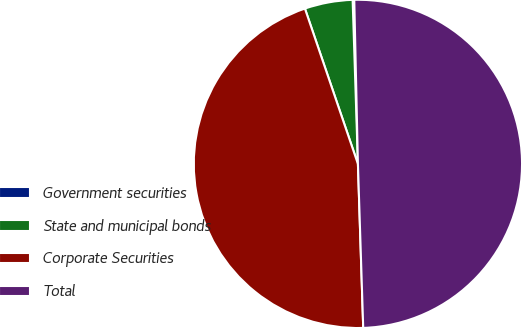<chart> <loc_0><loc_0><loc_500><loc_500><pie_chart><fcel>Government securities<fcel>State and municipal bonds<fcel>Corporate Securities<fcel>Total<nl><fcel>0.16%<fcel>4.72%<fcel>45.28%<fcel>49.84%<nl></chart> 